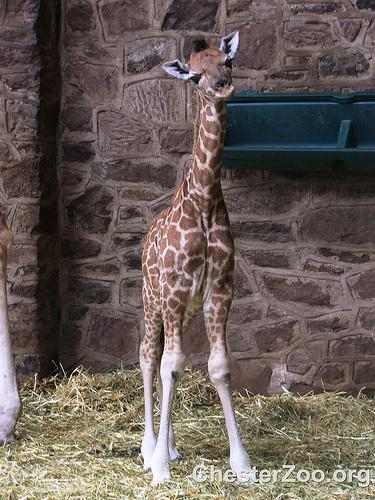Question: who is the giraffe looking at?
Choices:
A. The little girl.
B. The food.
C. The tree.
D. The photographer.
Answer with the letter. Answer: D Question: what color are the giraffes eyes?
Choices:
A. Yellow.
B. Brown.
C. They are black.
D. Green.
Answer with the letter. Answer: C Question: how many giraffes are there?
Choices:
A. 2.
B. 1.
C. 4.
D. 3.
Answer with the letter. Answer: A 